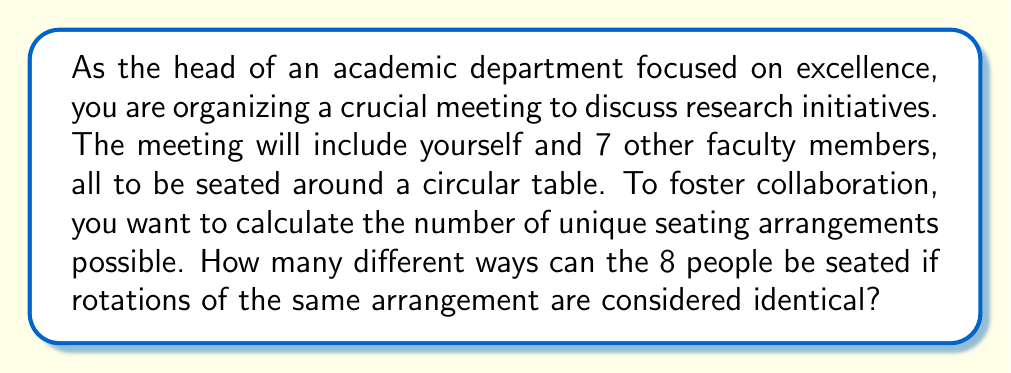What is the answer to this math problem? Let's approach this step-by-step:

1) We have 8 people in total to be seated around a circular table.

2) In a circular arrangement, rotations are considered the same. This means we can fix the position of one person (in this case, we'll fix your position as the department head) and arrange the rest.

3) After fixing your position, we need to arrange the remaining 7 faculty members.

4) This becomes a permutation problem. We're arranging 7 people in 7 spots.

5) The number of permutations of n distinct objects is given by $n!$.

6) In this case, $n = 7$, so we calculate $7!$:

   $$7! = 7 \times 6 \times 5 \times 4 \times 3 \times 2 \times 1 = 5040$$

Therefore, there are 5040 unique seating arrangements for the departmental meeting.
Answer: $5040$ 